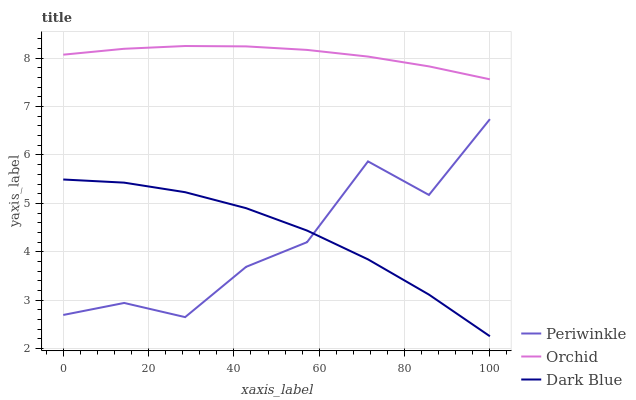Does Periwinkle have the minimum area under the curve?
Answer yes or no. Yes. Does Orchid have the maximum area under the curve?
Answer yes or no. Yes. Does Orchid have the minimum area under the curve?
Answer yes or no. No. Does Periwinkle have the maximum area under the curve?
Answer yes or no. No. Is Orchid the smoothest?
Answer yes or no. Yes. Is Periwinkle the roughest?
Answer yes or no. Yes. Is Periwinkle the smoothest?
Answer yes or no. No. Is Orchid the roughest?
Answer yes or no. No. Does Dark Blue have the lowest value?
Answer yes or no. Yes. Does Periwinkle have the lowest value?
Answer yes or no. No. Does Orchid have the highest value?
Answer yes or no. Yes. Does Periwinkle have the highest value?
Answer yes or no. No. Is Dark Blue less than Orchid?
Answer yes or no. Yes. Is Orchid greater than Periwinkle?
Answer yes or no. Yes. Does Dark Blue intersect Periwinkle?
Answer yes or no. Yes. Is Dark Blue less than Periwinkle?
Answer yes or no. No. Is Dark Blue greater than Periwinkle?
Answer yes or no. No. Does Dark Blue intersect Orchid?
Answer yes or no. No. 